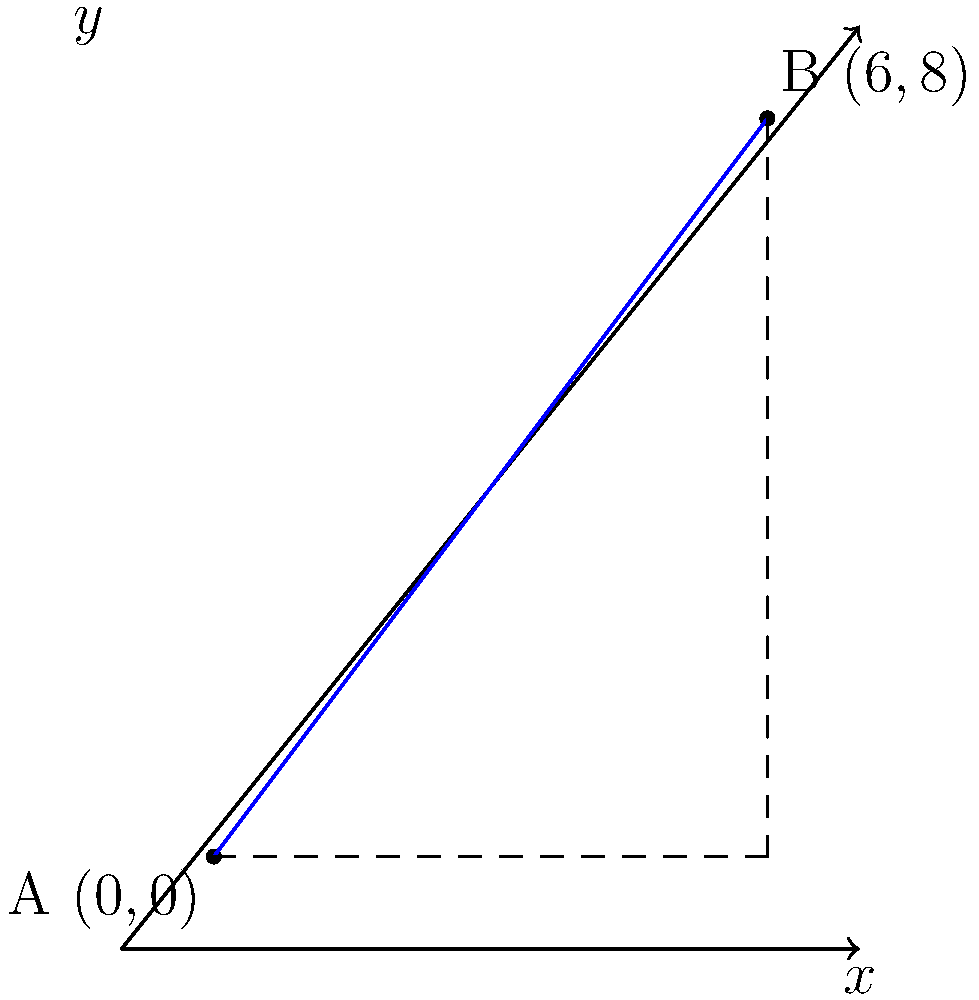As you document the village elder's agricultural wisdom, you learn about two ancestral farm plots. The elder describes their locations using a coordinate system, where each unit represents 100 meters. Plot A is located at (0,0), and Plot B is at (6,8). What is the shortest distance between these two farm plots in meters? To find the shortest distance between two points in a coordinate system, we can use the distance formula derived from the Pythagorean theorem:

$$d = \sqrt{(x_2 - x_1)^2 + (y_2 - y_1)^2}$$

Where $(x_1, y_1)$ are the coordinates of the first point and $(x_2, y_2)$ are the coordinates of the second point.

Given:
- Plot A: $(x_1, y_1) = (0, 0)$
- Plot B: $(x_2, y_2) = (6, 8)$

Let's substitute these values into the formula:

$$d = \sqrt{(6 - 0)^2 + (8 - 0)^2}$$

Simplify:
$$d = \sqrt{6^2 + 8^2}$$
$$d = \sqrt{36 + 64}$$
$$d = \sqrt{100}$$
$$d = 10$$

Since each unit represents 100 meters, we multiply our result by 100:

$$10 \times 100 = 1000\text{ meters}$$

Therefore, the shortest distance between the two farm plots is 1000 meters or 1 kilometer.
Answer: 1000 meters 